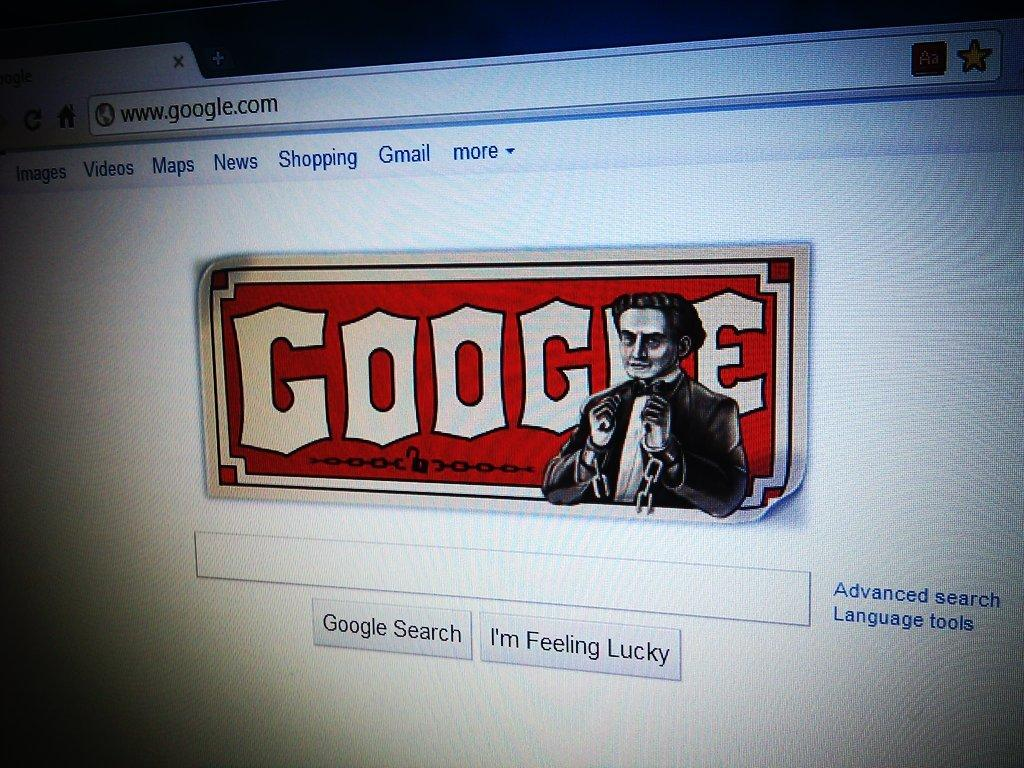<image>
Present a compact description of the photo's key features. The Google home page is presented on a screen. 